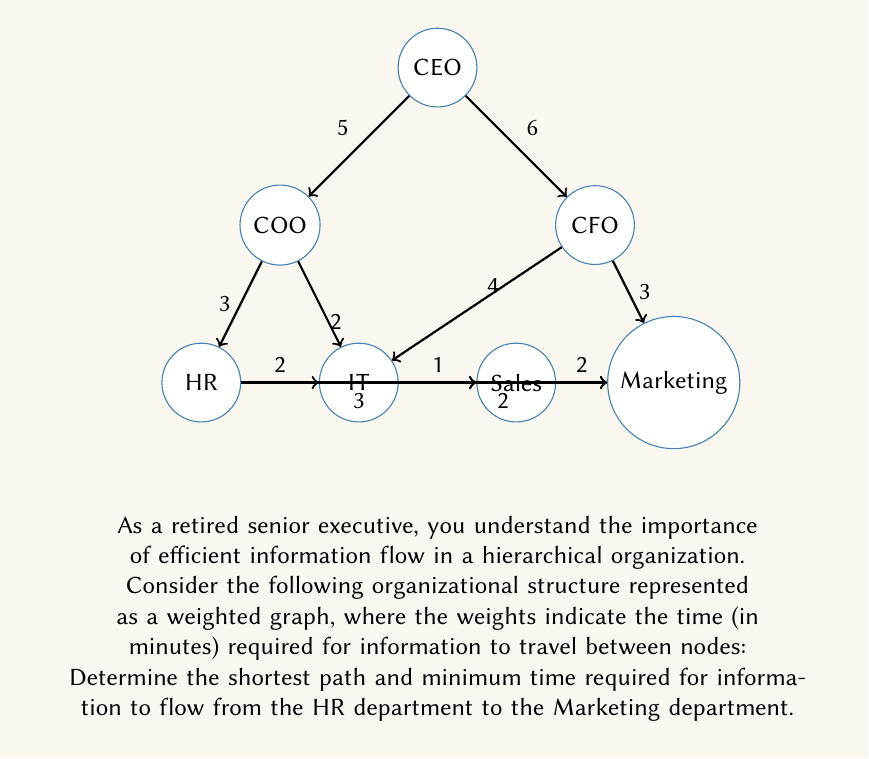Provide a solution to this math problem. To solve this problem, we'll use Dijkstra's algorithm to find the shortest path from the HR department (node D) to the Marketing department (node G). Let's go through the steps:

1) Initialize:
   - Set distance to HR (start node) as 0
   - Set distances to all other nodes as infinity
   - Set all nodes as unvisited

2) For the current node (starting with HR), consider all unvisited neighbors and calculate their tentative distances.
   - HR to IT: 2 minutes
   - HR to Sales: 3 minutes

3) Mark HR as visited. IT now has the smallest tentative distance (2 minutes), so we move to IT.

4) Update distances from IT:
   - IT to Sales: 2 + 1 = 3 minutes (shorter than direct HR to Sales)
   - IT to Marketing: 2 + 2 = 4 minutes
   - IT to COO: 2 + 2 = 4 minutes
   - IT to CFO: 2 + 4 = 6 minutes

5) Mark IT as visited. Sales now has the smallest tentative distance (3 minutes), so we move to Sales.

6) Update distances from Sales:
   - Sales to Marketing: 3 + 2 = 5 minutes (shorter than IT to Marketing)

7) Mark Sales as visited. Marketing now has the smallest tentative distance (5 minutes), which is our destination.

The shortest path is: HR → IT → Sales → Marketing
The total time required is 5 minutes.
Answer: HR → IT → Sales → Marketing, 5 minutes 